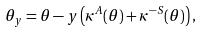<formula> <loc_0><loc_0><loc_500><loc_500>\theta _ { y } = \theta - y \left ( \kappa ^ { A } ( \theta ) + \kappa ^ { - S } ( \theta ) \right ) ,</formula> 